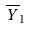Convert formula to latex. <formula><loc_0><loc_0><loc_500><loc_500>\overline { Y } _ { 1 }</formula> 